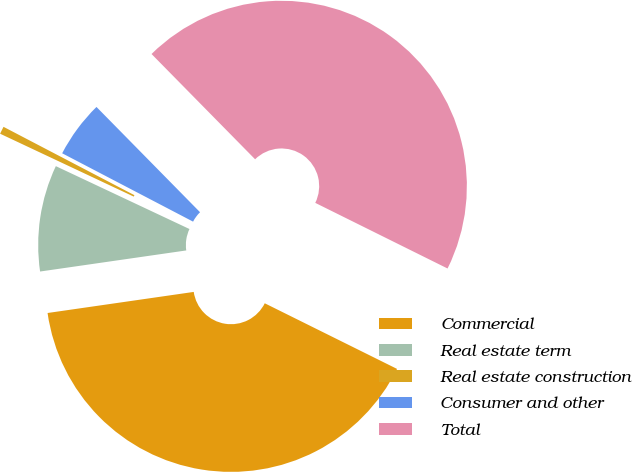Convert chart to OTSL. <chart><loc_0><loc_0><loc_500><loc_500><pie_chart><fcel>Commercial<fcel>Real estate term<fcel>Real estate construction<fcel>Consumer and other<fcel>Total<nl><fcel>40.39%<fcel>9.28%<fcel>0.66%<fcel>4.97%<fcel>44.7%<nl></chart> 